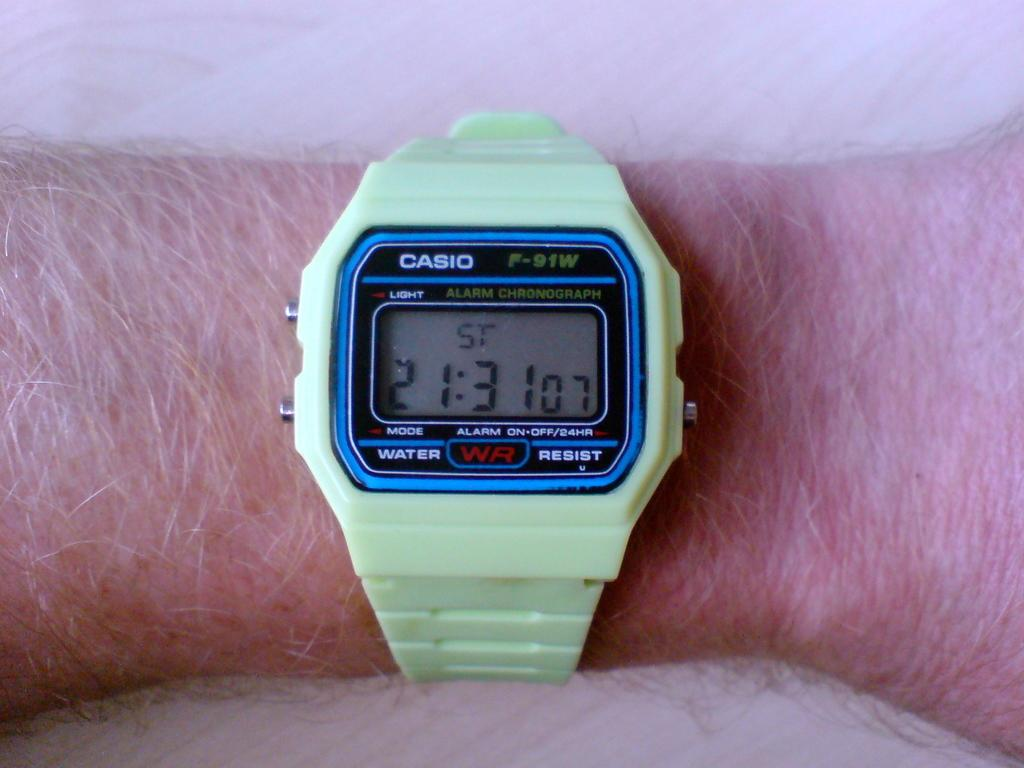<image>
Share a concise interpretation of the image provided. A green casio wrist watch on a mans wrist 